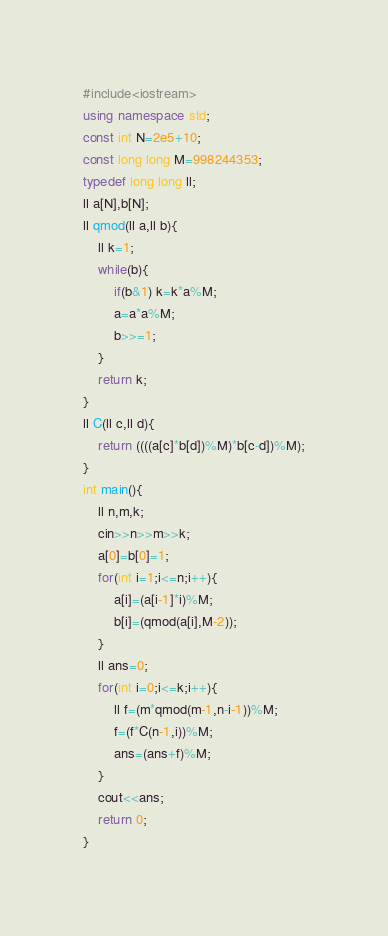<code> <loc_0><loc_0><loc_500><loc_500><_C++_>#include<iostream>
using namespace std;
const int N=2e5+10;
const long long M=998244353;
typedef long long ll;
ll a[N],b[N];
ll qmod(ll a,ll b){
	ll k=1;
	while(b){
		if(b&1) k=k*a%M;
		a=a*a%M;
		b>>=1;
	}
	return k;
}
ll C(ll c,ll d){
	return ((((a[c]*b[d])%M)*b[c-d])%M);
}
int main(){
	ll n,m,k;
	cin>>n>>m>>k;
	a[0]=b[0]=1;
	for(int i=1;i<=n;i++){
		a[i]=(a[i-1]*i)%M;
		b[i]=(qmod(a[i],M-2));
	}
	ll ans=0;
	for(int i=0;i<=k;i++){
		ll f=(m*qmod(m-1,n-i-1))%M;
		f=(f*C(n-1,i))%M;
		ans=(ans+f)%M;
	}
	cout<<ans;
	return 0;
}
</code> 